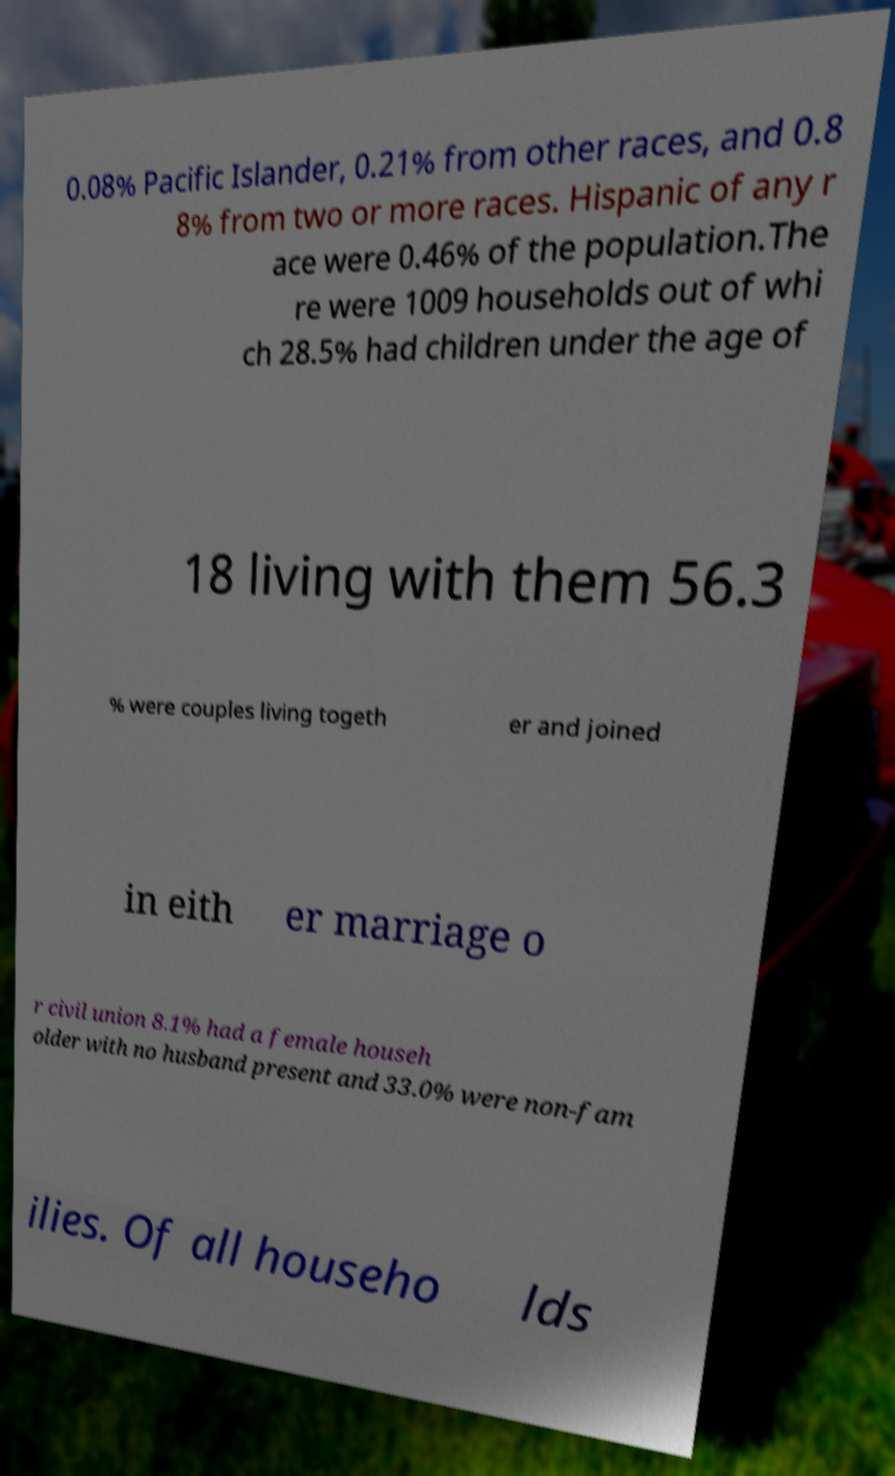Could you assist in decoding the text presented in this image and type it out clearly? 0.08% Pacific Islander, 0.21% from other races, and 0.8 8% from two or more races. Hispanic of any r ace were 0.46% of the population.The re were 1009 households out of whi ch 28.5% had children under the age of 18 living with them 56.3 % were couples living togeth er and joined in eith er marriage o r civil union 8.1% had a female househ older with no husband present and 33.0% were non-fam ilies. Of all househo lds 